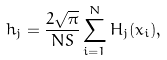<formula> <loc_0><loc_0><loc_500><loc_500>h _ { j } = \frac { 2 \sqrt { \pi } } { N S } \sum ^ { N } _ { i = 1 } H _ { j } ( x _ { i } ) ,</formula> 